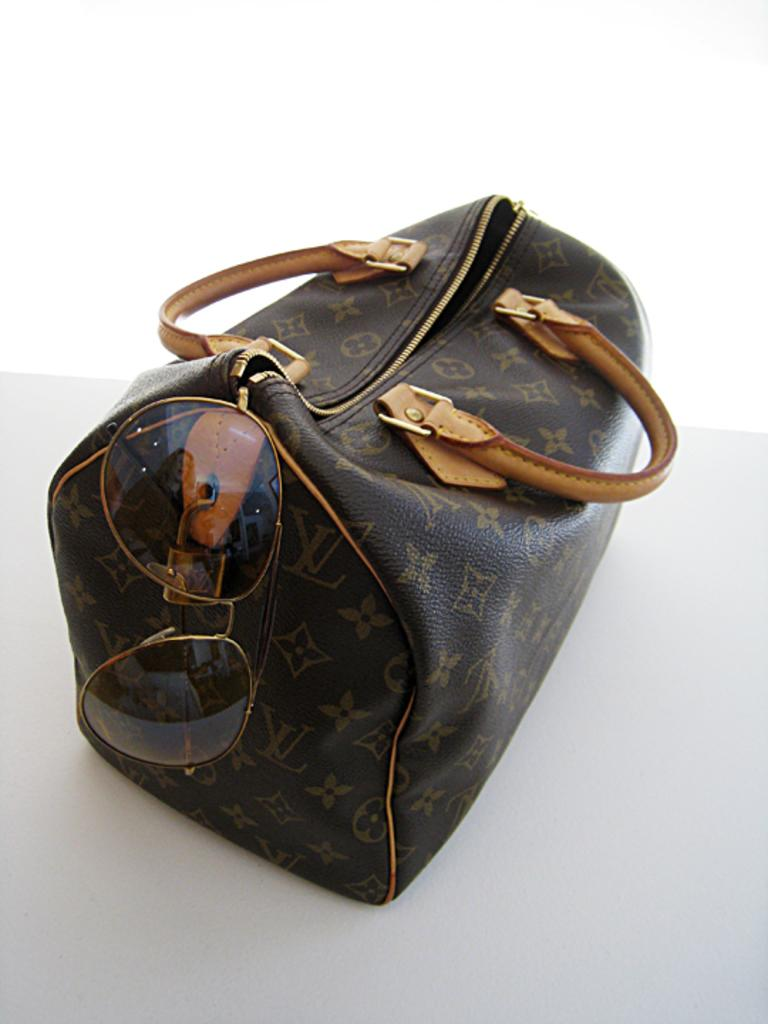What is the color of the bag in the image? The bag in the image is black. What is attached to the black bag? Goggles are attached to the black bag. Can you find the receipt for the celery purchase in the image? There is no receipt or celery present in the image; it only features a black bag with goggles attached. 